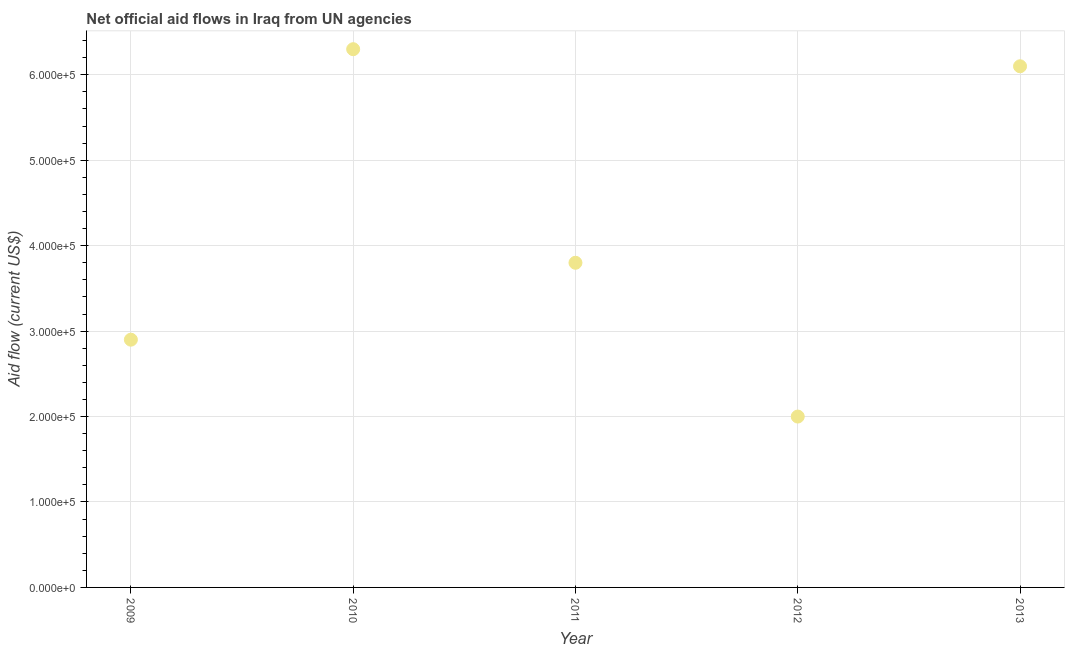What is the net official flows from un agencies in 2010?
Provide a short and direct response. 6.30e+05. Across all years, what is the maximum net official flows from un agencies?
Your answer should be very brief. 6.30e+05. Across all years, what is the minimum net official flows from un agencies?
Keep it short and to the point. 2.00e+05. In which year was the net official flows from un agencies maximum?
Provide a succinct answer. 2010. In which year was the net official flows from un agencies minimum?
Offer a terse response. 2012. What is the sum of the net official flows from un agencies?
Your response must be concise. 2.11e+06. What is the difference between the net official flows from un agencies in 2010 and 2011?
Give a very brief answer. 2.50e+05. What is the average net official flows from un agencies per year?
Your response must be concise. 4.22e+05. What is the median net official flows from un agencies?
Your answer should be very brief. 3.80e+05. Do a majority of the years between 2013 and 2010 (inclusive) have net official flows from un agencies greater than 180000 US$?
Offer a terse response. Yes. What is the ratio of the net official flows from un agencies in 2011 to that in 2013?
Your answer should be compact. 0.62. Is the net official flows from un agencies in 2011 less than that in 2012?
Your answer should be very brief. No. Is the difference between the net official flows from un agencies in 2009 and 2011 greater than the difference between any two years?
Give a very brief answer. No. Is the sum of the net official flows from un agencies in 2009 and 2012 greater than the maximum net official flows from un agencies across all years?
Give a very brief answer. No. What is the difference between the highest and the lowest net official flows from un agencies?
Provide a succinct answer. 4.30e+05. In how many years, is the net official flows from un agencies greater than the average net official flows from un agencies taken over all years?
Ensure brevity in your answer.  2. Does the net official flows from un agencies monotonically increase over the years?
Provide a short and direct response. No. Are the values on the major ticks of Y-axis written in scientific E-notation?
Your response must be concise. Yes. Does the graph contain grids?
Keep it short and to the point. Yes. What is the title of the graph?
Offer a terse response. Net official aid flows in Iraq from UN agencies. What is the Aid flow (current US$) in 2010?
Give a very brief answer. 6.30e+05. What is the difference between the Aid flow (current US$) in 2009 and 2010?
Give a very brief answer. -3.40e+05. What is the difference between the Aid flow (current US$) in 2009 and 2012?
Ensure brevity in your answer.  9.00e+04. What is the difference between the Aid flow (current US$) in 2009 and 2013?
Offer a very short reply. -3.20e+05. What is the difference between the Aid flow (current US$) in 2011 and 2012?
Provide a short and direct response. 1.80e+05. What is the difference between the Aid flow (current US$) in 2011 and 2013?
Keep it short and to the point. -2.30e+05. What is the difference between the Aid flow (current US$) in 2012 and 2013?
Provide a succinct answer. -4.10e+05. What is the ratio of the Aid flow (current US$) in 2009 to that in 2010?
Your response must be concise. 0.46. What is the ratio of the Aid flow (current US$) in 2009 to that in 2011?
Offer a terse response. 0.76. What is the ratio of the Aid flow (current US$) in 2009 to that in 2012?
Ensure brevity in your answer.  1.45. What is the ratio of the Aid flow (current US$) in 2009 to that in 2013?
Your answer should be compact. 0.47. What is the ratio of the Aid flow (current US$) in 2010 to that in 2011?
Make the answer very short. 1.66. What is the ratio of the Aid flow (current US$) in 2010 to that in 2012?
Your answer should be compact. 3.15. What is the ratio of the Aid flow (current US$) in 2010 to that in 2013?
Your response must be concise. 1.03. What is the ratio of the Aid flow (current US$) in 2011 to that in 2013?
Ensure brevity in your answer.  0.62. What is the ratio of the Aid flow (current US$) in 2012 to that in 2013?
Provide a succinct answer. 0.33. 